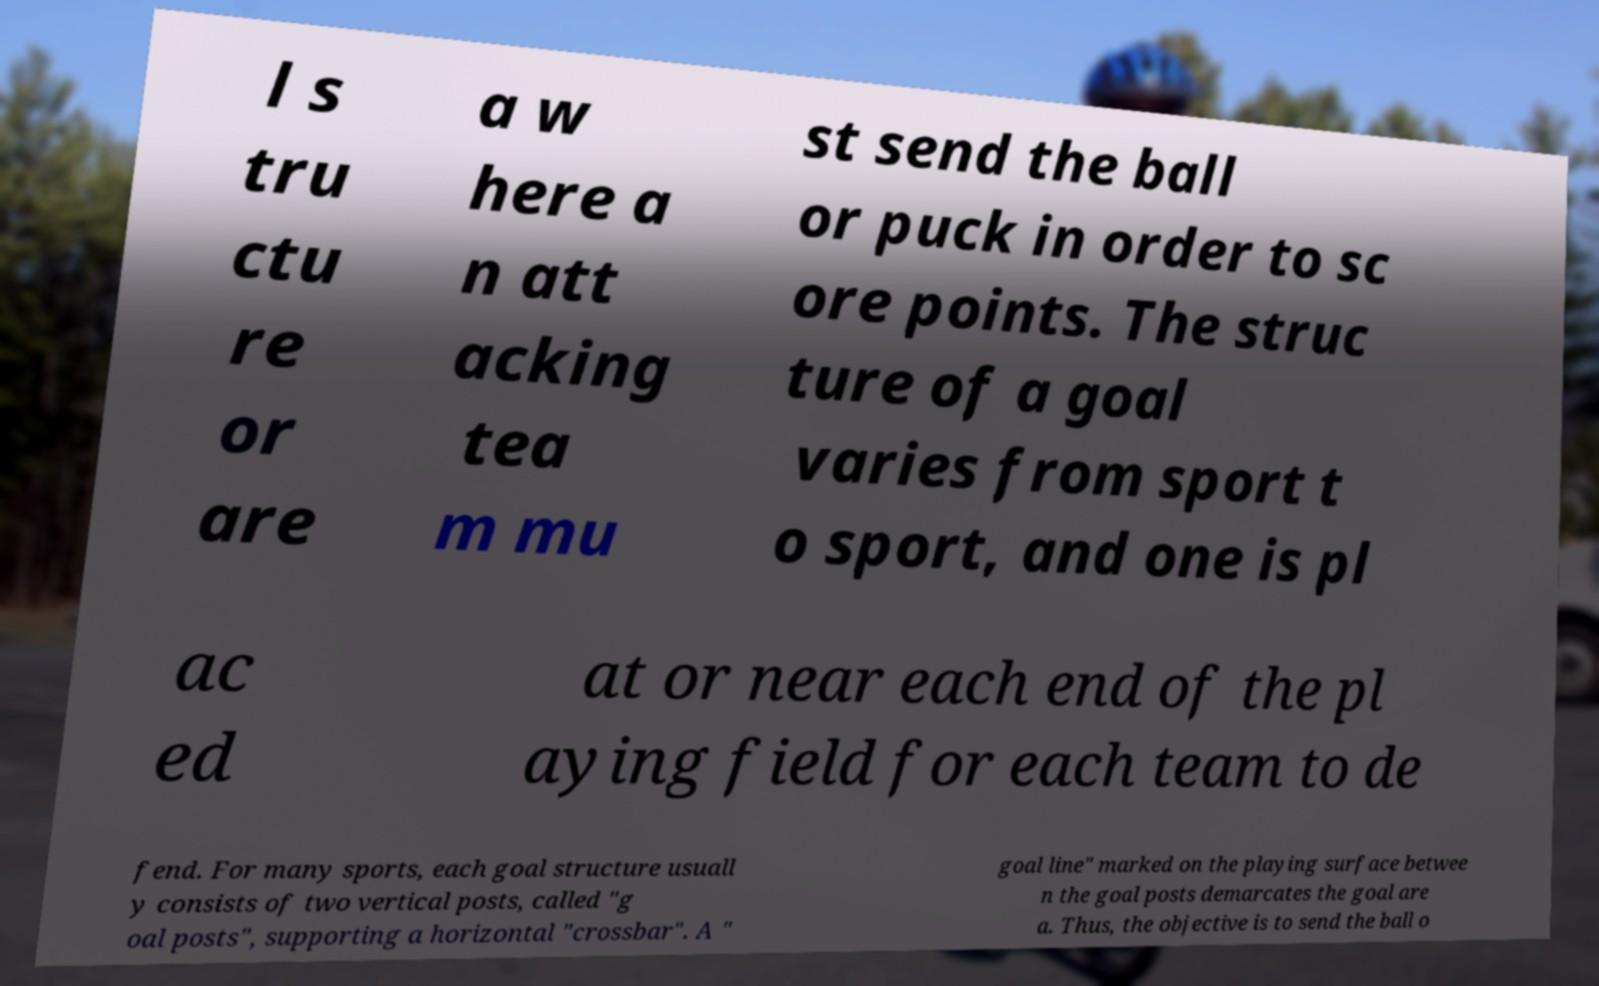Could you extract and type out the text from this image? l s tru ctu re or are a w here a n att acking tea m mu st send the ball or puck in order to sc ore points. The struc ture of a goal varies from sport t o sport, and one is pl ac ed at or near each end of the pl aying field for each team to de fend. For many sports, each goal structure usuall y consists of two vertical posts, called "g oal posts", supporting a horizontal "crossbar". A " goal line" marked on the playing surface betwee n the goal posts demarcates the goal are a. Thus, the objective is to send the ball o 